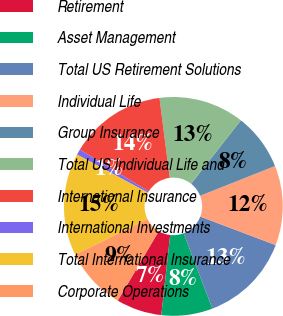<chart> <loc_0><loc_0><loc_500><loc_500><pie_chart><fcel>Retirement<fcel>Asset Management<fcel>Total US Retirement Solutions<fcel>Individual Life<fcel>Group Insurance<fcel>Total US Individual Life and<fcel>International Insurance<fcel>International Investments<fcel>Total International Insurance<fcel>Corporate Operations<nl><fcel>6.72%<fcel>7.56%<fcel>13.44%<fcel>11.76%<fcel>8.4%<fcel>12.6%<fcel>14.28%<fcel>0.84%<fcel>15.12%<fcel>9.24%<nl></chart> 